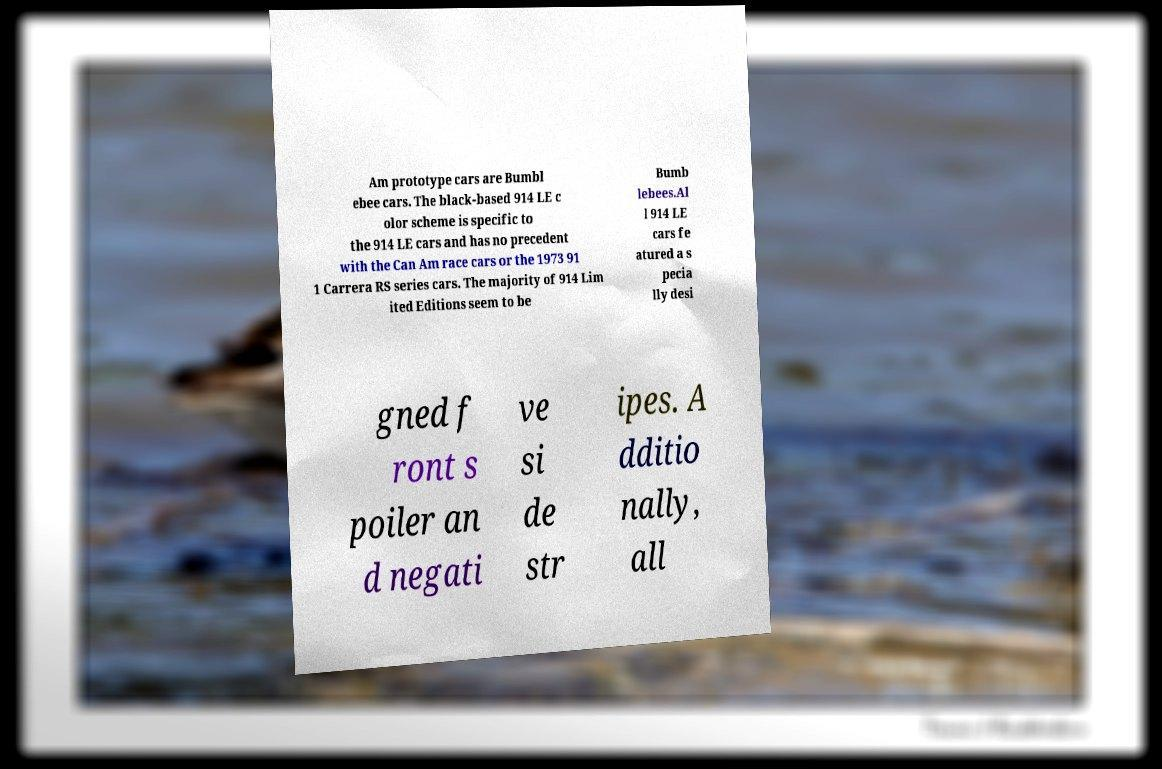Could you assist in decoding the text presented in this image and type it out clearly? Am prototype cars are Bumbl ebee cars. The black-based 914 LE c olor scheme is specific to the 914 LE cars and has no precedent with the Can Am race cars or the 1973 91 1 Carrera RS series cars. The majority of 914 Lim ited Editions seem to be Bumb lebees.Al l 914 LE cars fe atured a s pecia lly desi gned f ront s poiler an d negati ve si de str ipes. A dditio nally, all 